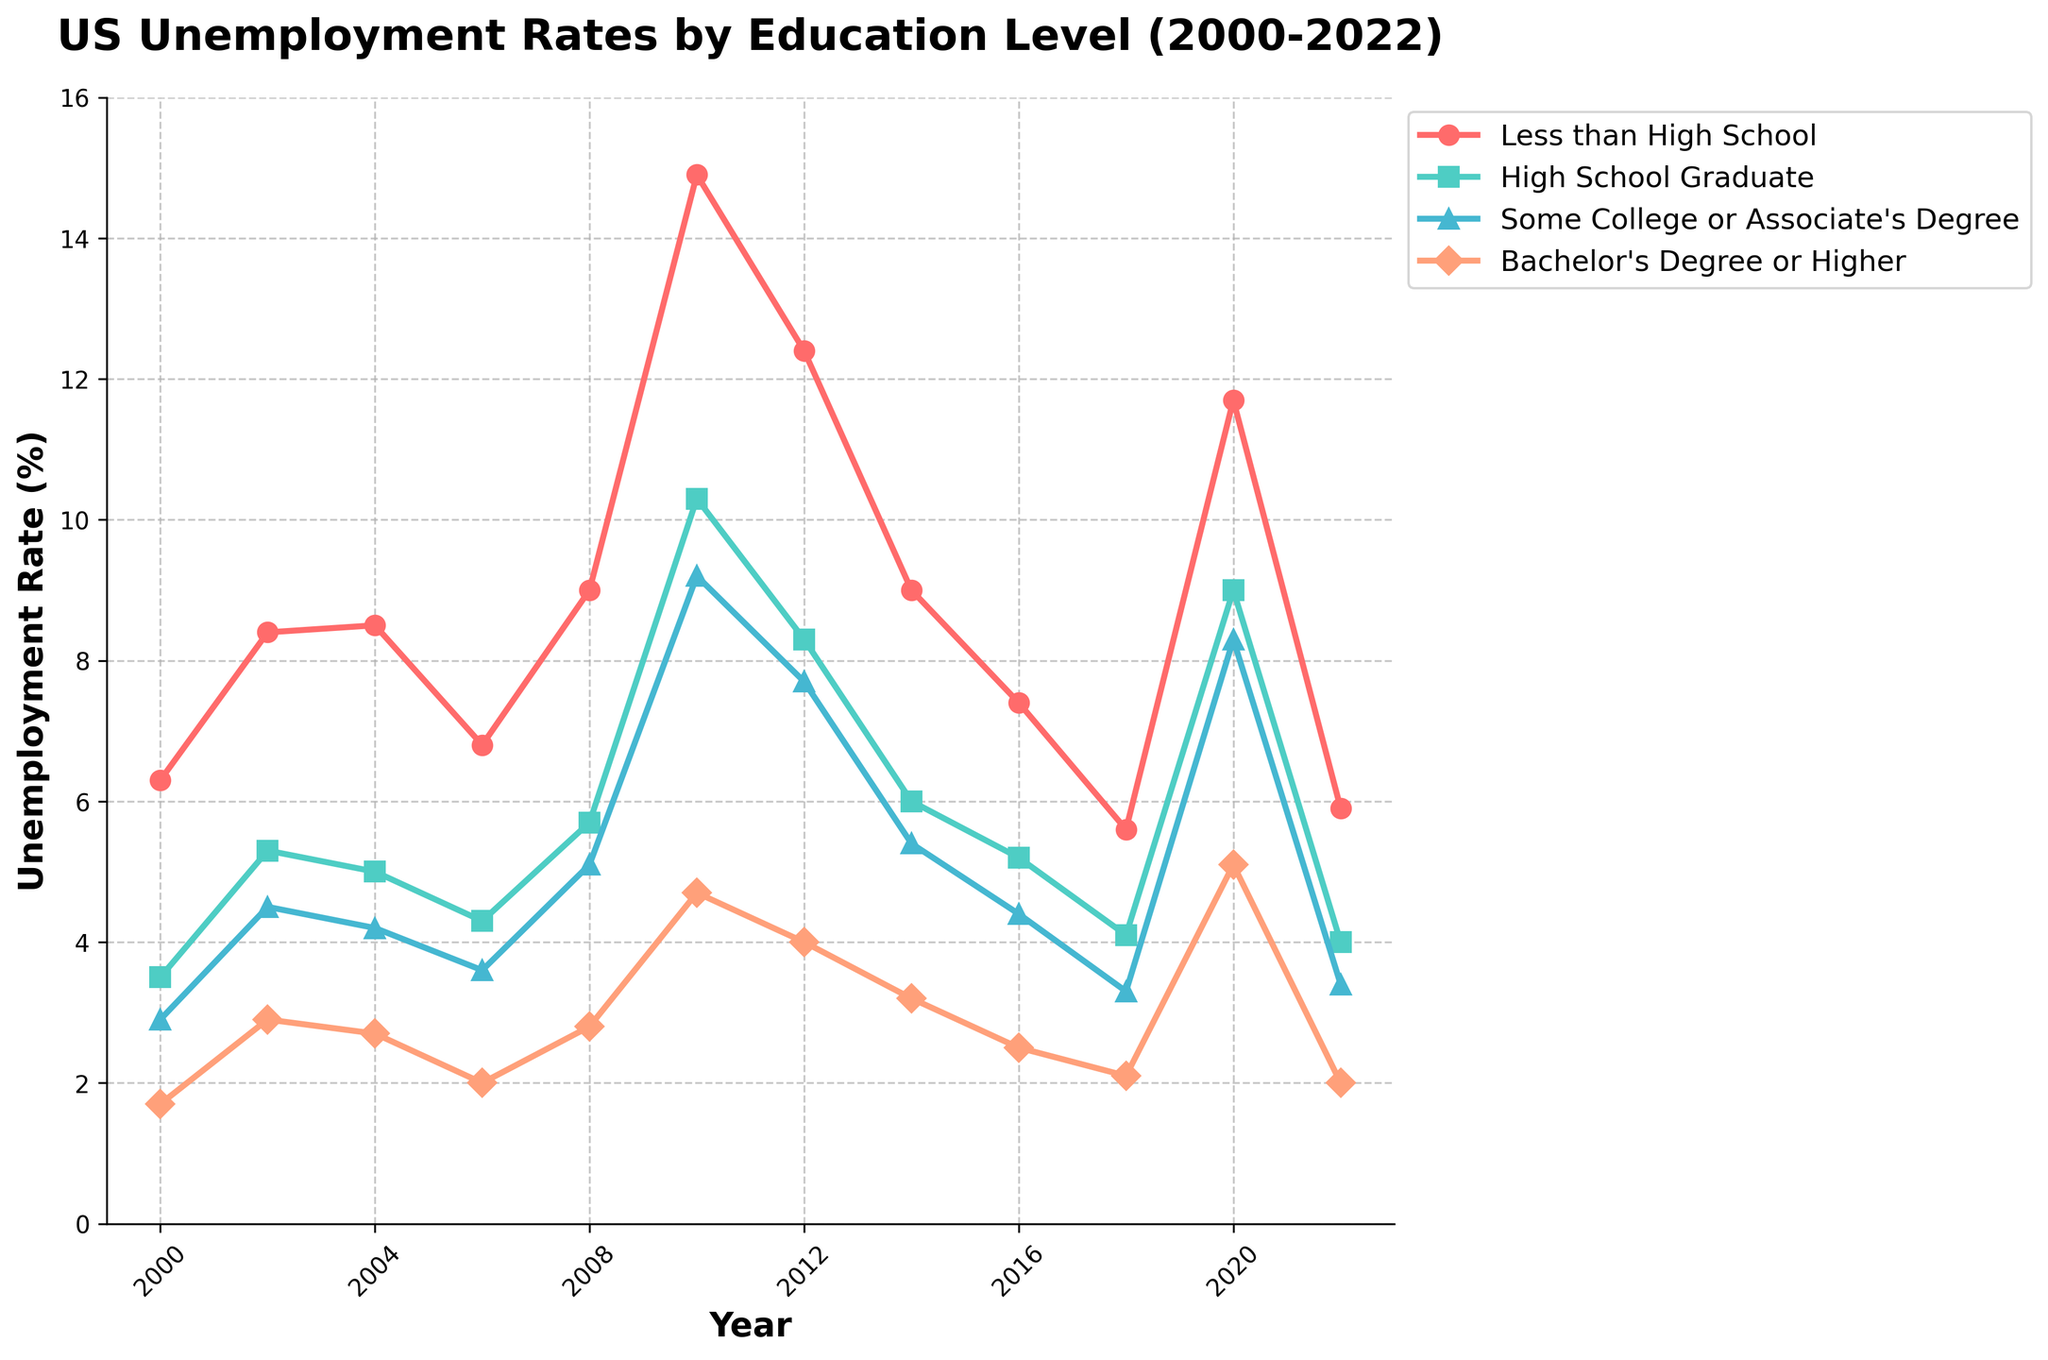What was the trend in unemployment rates for those with a Bachelor's Degree or Higher between 2000 and 2010? The unemployment rate for those with a Bachelor's Degree or Higher started at 1.7% in 2000, increased to 2.9% in 2002, slightly decreased to 2.7% in 2004, then rose slightly to 2.8% in 2008, and sharply increased to 4.7% in 2010.
Answer: Increased During which year did those with Less than a High School diploma experience the highest unemployment rate? The highest unemployment rate for those with Less than High School was in 2010, where it reached 14.9%.
Answer: 2010 How did the unemployment rate for High School Graduates in 2020 compare to the rate for Some College or Associate's Degree in the same year? In 2020, the unemployment rate for High School Graduates was 9.0%, whereas it was 8.3% for those with Some College or Associate's Degree.
Answer: Higher What is the difference in the unemployment rates for those with a Bachelor's Degree or Higher between 2000 and 2022? In 2000, the rate was 1.7%. In 2022, it was 2.0%. The difference is 2.0% - 1.7% = 0.3%.
Answer: 0.3% Which education level consistently had the lowest unemployment rate throughout the period? The Bachelor's Degree or Higher consistently had the lowest unemployment rates from 2000 to 2022, as seen by the lower position of this line compared to others in the figure.
Answer: Bachelor's Degree or Higher In which year did all education levels experience a peak in unemployment rate? In 2010, all education levels reached their highest unemployment rates simultaneously.
Answer: 2010 What was the average unemployment rate for Some College or Associate's Degree over the period? The average is calculated by summing the unemployment rates for Some College or Associate's Degree from the data provided (2.9 + 4.5 + 4.2 + 3.6 + 5.1 + 9.2 + 7.7 + 5.4 + 4.4 + 3.3 + 8.3 + 3.4) and then dividing by the number of years, which is 12. Therefore, the average is (62.0 / 12) = 5.17%.
Answer: 5.17% In 2012, how much higher was the unemployment rate for those with Less than a High School diploma compared to those with a High School diploma? In 2012, the rate for Less than a High School was 12.4%, and for High School Graduate, it was 8.3%. The difference is 12.4% - 8.3% = 4.1%.
Answer: 4.1% Which year saw the most significant drop in unemployment rate for Less than High School education from the previous recorded year? The most significant drop was between 2010 (14.9%) and 2012 (12.4%), a decrease of 14.9% - 12.4% = 2.5%.
Answer: 2012 